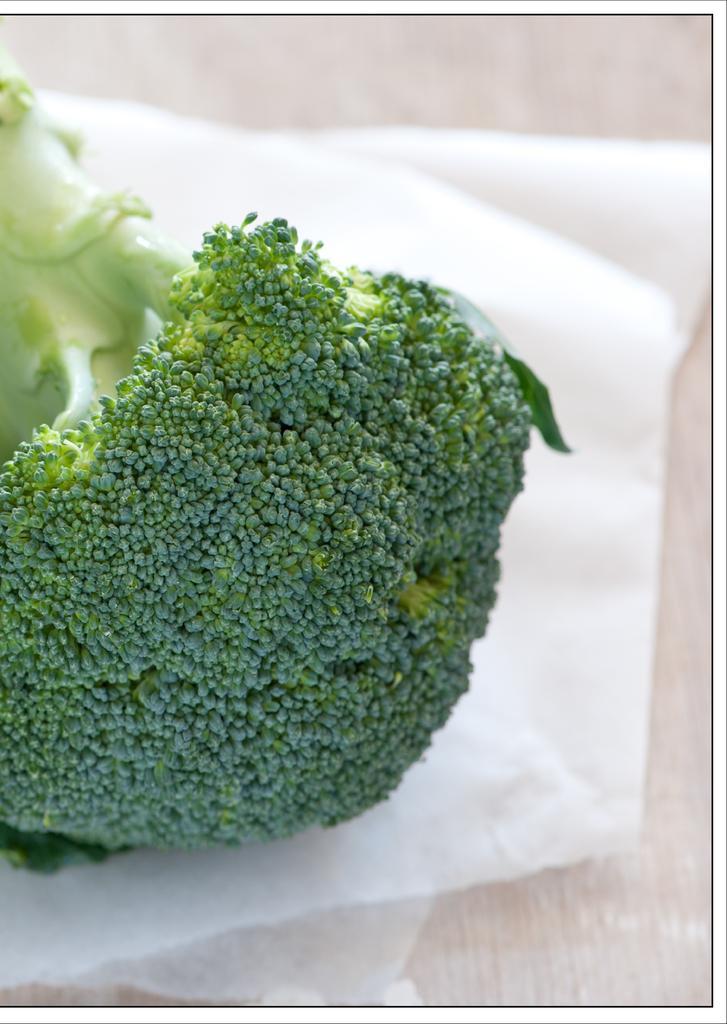In one or two sentences, can you explain what this image depicts? In this image we can see a broccoli on the paper. 